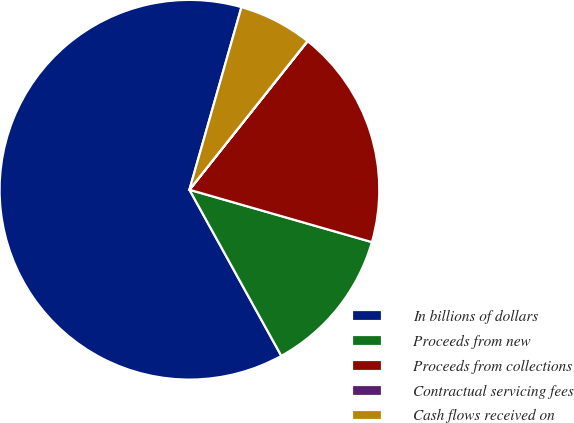Convert chart to OTSL. <chart><loc_0><loc_0><loc_500><loc_500><pie_chart><fcel>In billions of dollars<fcel>Proceeds from new<fcel>Proceeds from collections<fcel>Contractual servicing fees<fcel>Cash flows received on<nl><fcel>62.45%<fcel>12.51%<fcel>18.75%<fcel>0.02%<fcel>6.26%<nl></chart> 